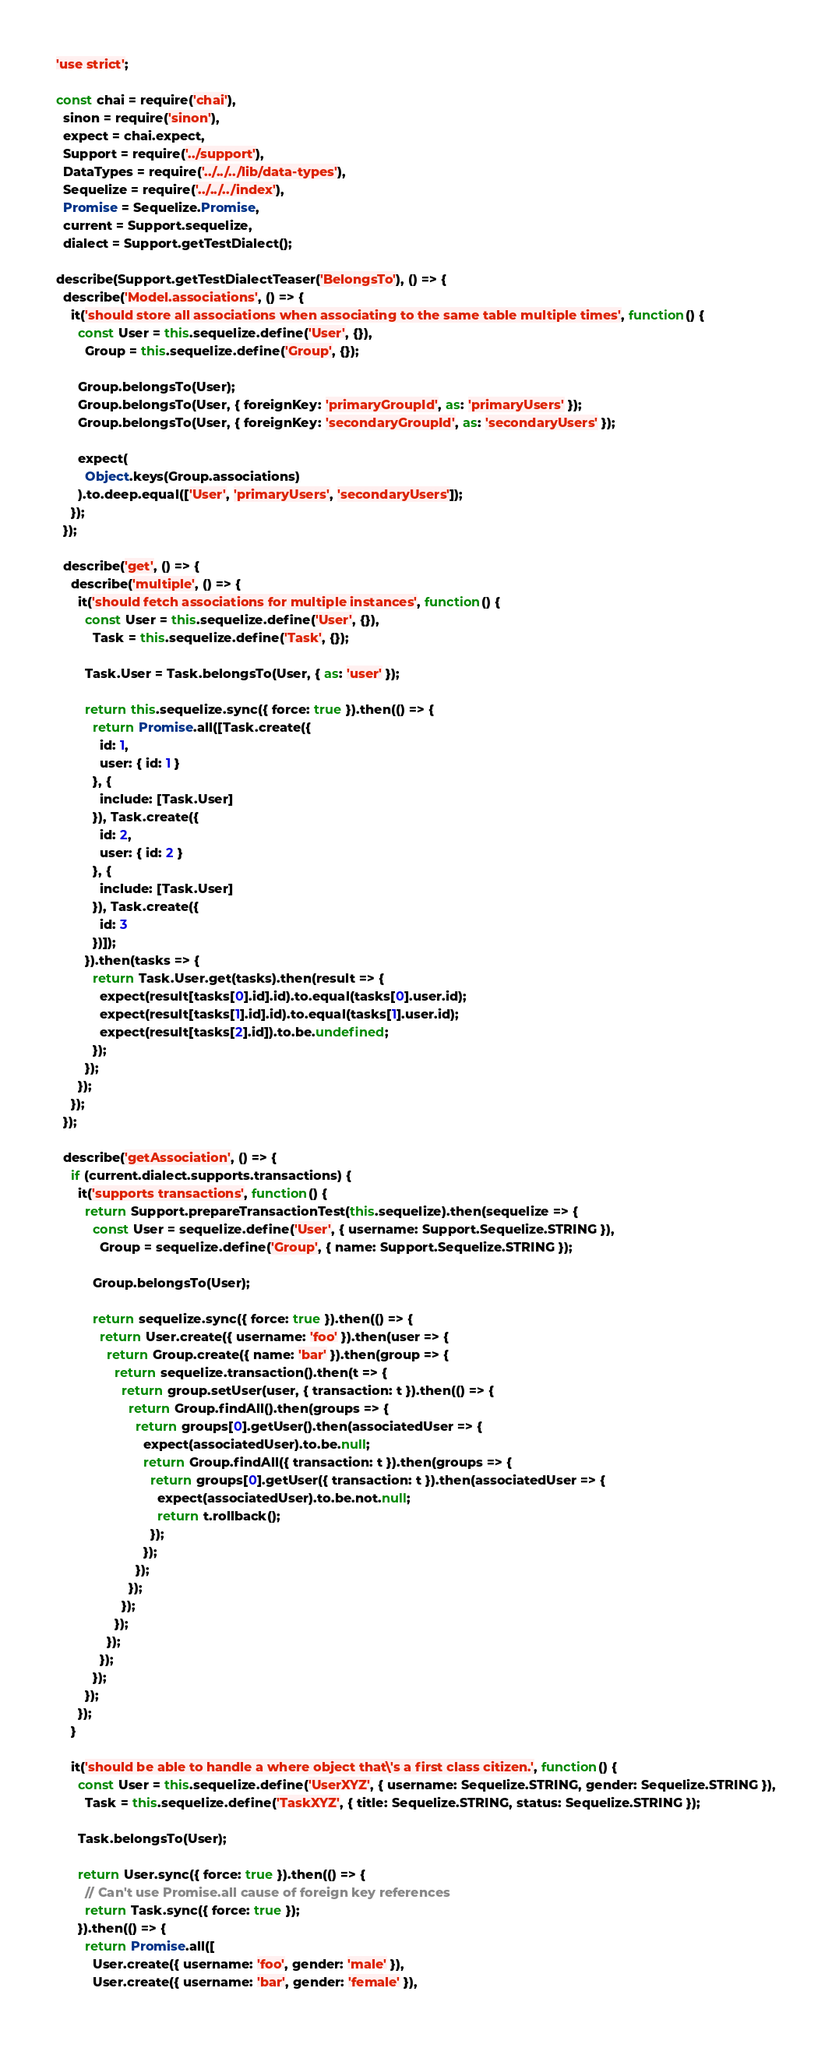<code> <loc_0><loc_0><loc_500><loc_500><_JavaScript_>'use strict';

const chai = require('chai'),
  sinon = require('sinon'),
  expect = chai.expect,
  Support = require('../support'),
  DataTypes = require('../../../lib/data-types'),
  Sequelize = require('../../../index'),
  Promise = Sequelize.Promise,
  current = Support.sequelize,
  dialect = Support.getTestDialect();

describe(Support.getTestDialectTeaser('BelongsTo'), () => {
  describe('Model.associations', () => {
    it('should store all associations when associating to the same table multiple times', function() {
      const User = this.sequelize.define('User', {}),
        Group = this.sequelize.define('Group', {});

      Group.belongsTo(User);
      Group.belongsTo(User, { foreignKey: 'primaryGroupId', as: 'primaryUsers' });
      Group.belongsTo(User, { foreignKey: 'secondaryGroupId', as: 'secondaryUsers' });

      expect(
        Object.keys(Group.associations)
      ).to.deep.equal(['User', 'primaryUsers', 'secondaryUsers']);
    });
  });

  describe('get', () => {
    describe('multiple', () => {
      it('should fetch associations for multiple instances', function() {
        const User = this.sequelize.define('User', {}),
          Task = this.sequelize.define('Task', {});

        Task.User = Task.belongsTo(User, { as: 'user' });

        return this.sequelize.sync({ force: true }).then(() => {
          return Promise.all([Task.create({
            id: 1,
            user: { id: 1 }
          }, {
            include: [Task.User]
          }), Task.create({
            id: 2,
            user: { id: 2 }
          }, {
            include: [Task.User]
          }), Task.create({
            id: 3
          })]);
        }).then(tasks => {
          return Task.User.get(tasks).then(result => {
            expect(result[tasks[0].id].id).to.equal(tasks[0].user.id);
            expect(result[tasks[1].id].id).to.equal(tasks[1].user.id);
            expect(result[tasks[2].id]).to.be.undefined;
          });
        });
      });
    });
  });

  describe('getAssociation', () => {
    if (current.dialect.supports.transactions) {
      it('supports transactions', function() {
        return Support.prepareTransactionTest(this.sequelize).then(sequelize => {
          const User = sequelize.define('User', { username: Support.Sequelize.STRING }),
            Group = sequelize.define('Group', { name: Support.Sequelize.STRING });

          Group.belongsTo(User);

          return sequelize.sync({ force: true }).then(() => {
            return User.create({ username: 'foo' }).then(user => {
              return Group.create({ name: 'bar' }).then(group => {
                return sequelize.transaction().then(t => {
                  return group.setUser(user, { transaction: t }).then(() => {
                    return Group.findAll().then(groups => {
                      return groups[0].getUser().then(associatedUser => {
                        expect(associatedUser).to.be.null;
                        return Group.findAll({ transaction: t }).then(groups => {
                          return groups[0].getUser({ transaction: t }).then(associatedUser => {
                            expect(associatedUser).to.be.not.null;
                            return t.rollback();
                          });
                        });
                      });
                    });
                  });
                });
              });
            });
          });
        });
      });
    }

    it('should be able to handle a where object that\'s a first class citizen.', function() {
      const User = this.sequelize.define('UserXYZ', { username: Sequelize.STRING, gender: Sequelize.STRING }),
        Task = this.sequelize.define('TaskXYZ', { title: Sequelize.STRING, status: Sequelize.STRING });

      Task.belongsTo(User);

      return User.sync({ force: true }).then(() => {
        // Can't use Promise.all cause of foreign key references
        return Task.sync({ force: true });
      }).then(() => {
        return Promise.all([
          User.create({ username: 'foo', gender: 'male' }),
          User.create({ username: 'bar', gender: 'female' }),</code> 